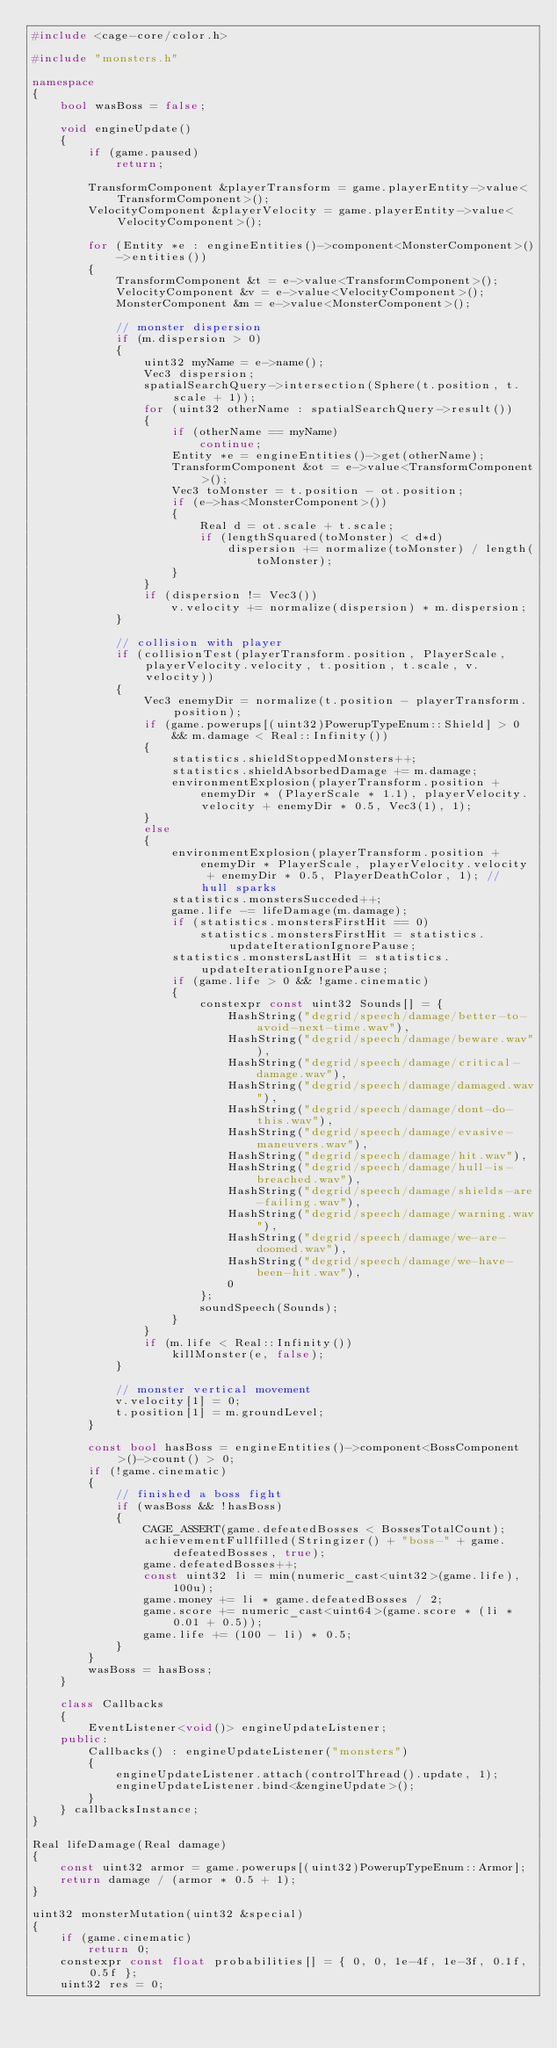Convert code to text. <code><loc_0><loc_0><loc_500><loc_500><_C++_>#include <cage-core/color.h>

#include "monsters.h"

namespace
{
	bool wasBoss = false;

	void engineUpdate()
	{
		if (game.paused)
			return;

		TransformComponent &playerTransform = game.playerEntity->value<TransformComponent>();
		VelocityComponent &playerVelocity = game.playerEntity->value<VelocityComponent>();

		for (Entity *e : engineEntities()->component<MonsterComponent>()->entities())
		{
			TransformComponent &t = e->value<TransformComponent>();
			VelocityComponent &v = e->value<VelocityComponent>();
			MonsterComponent &m = e->value<MonsterComponent>();

			// monster dispersion
			if (m.dispersion > 0)
			{
				uint32 myName = e->name();
				Vec3 dispersion;
				spatialSearchQuery->intersection(Sphere(t.position, t.scale + 1));
				for (uint32 otherName : spatialSearchQuery->result())
				{
					if (otherName == myName)
						continue;
					Entity *e = engineEntities()->get(otherName);
					TransformComponent &ot = e->value<TransformComponent>();
					Vec3 toMonster = t.position - ot.position;
					if (e->has<MonsterComponent>())
					{
						Real d = ot.scale + t.scale;
						if (lengthSquared(toMonster) < d*d)
							dispersion += normalize(toMonster) / length(toMonster);
					}
				}
				if (dispersion != Vec3())
					v.velocity += normalize(dispersion) * m.dispersion;
			}

			// collision with player
			if (collisionTest(playerTransform.position, PlayerScale, playerVelocity.velocity, t.position, t.scale, v.velocity))
			{
				Vec3 enemyDir = normalize(t.position - playerTransform.position);
				if (game.powerups[(uint32)PowerupTypeEnum::Shield] > 0 && m.damage < Real::Infinity())
				{
					statistics.shieldStoppedMonsters++;
					statistics.shieldAbsorbedDamage += m.damage;
					environmentExplosion(playerTransform.position + enemyDir * (PlayerScale * 1.1), playerVelocity.velocity + enemyDir * 0.5, Vec3(1), 1); 
				}
				else
				{
					environmentExplosion(playerTransform.position + enemyDir * PlayerScale, playerVelocity.velocity + enemyDir * 0.5, PlayerDeathColor, 1); // hull sparks
					statistics.monstersSucceded++;
					game.life -= lifeDamage(m.damage);
					if (statistics.monstersFirstHit == 0)
						statistics.monstersFirstHit = statistics.updateIterationIgnorePause;
					statistics.monstersLastHit = statistics.updateIterationIgnorePause;
					if (game.life > 0 && !game.cinematic)
					{
						constexpr const uint32 Sounds[] = {
							HashString("degrid/speech/damage/better-to-avoid-next-time.wav"),
							HashString("degrid/speech/damage/beware.wav"),
							HashString("degrid/speech/damage/critical-damage.wav"),
							HashString("degrid/speech/damage/damaged.wav"),
							HashString("degrid/speech/damage/dont-do-this.wav"),
							HashString("degrid/speech/damage/evasive-maneuvers.wav"),
							HashString("degrid/speech/damage/hit.wav"),
							HashString("degrid/speech/damage/hull-is-breached.wav"),
							HashString("degrid/speech/damage/shields-are-failing.wav"),
							HashString("degrid/speech/damage/warning.wav"),
							HashString("degrid/speech/damage/we-are-doomed.wav"),
							HashString("degrid/speech/damage/we-have-been-hit.wav"),
							0
						};
						soundSpeech(Sounds);
					}
				}
				if (m.life < Real::Infinity())
					killMonster(e, false);
			}

			// monster vertical movement
			v.velocity[1] = 0;
			t.position[1] = m.groundLevel;
		}

		const bool hasBoss = engineEntities()->component<BossComponent>()->count() > 0;
		if (!game.cinematic)
		{
			// finished a boss fight
			if (wasBoss && !hasBoss)
			{
				CAGE_ASSERT(game.defeatedBosses < BossesTotalCount);
				achievementFullfilled(Stringizer() + "boss-" + game.defeatedBosses, true);
				game.defeatedBosses++;
				const uint32 li = min(numeric_cast<uint32>(game.life), 100u);
				game.money += li * game.defeatedBosses / 2;
				game.score += numeric_cast<uint64>(game.score * (li * 0.01 + 0.5));
				game.life += (100 - li) * 0.5;
			}
		}
		wasBoss = hasBoss;
	}

	class Callbacks
	{
		EventListener<void()> engineUpdateListener;
	public:
		Callbacks() : engineUpdateListener("monsters")
		{
			engineUpdateListener.attach(controlThread().update, 1);
			engineUpdateListener.bind<&engineUpdate>();
		}
	} callbacksInstance;
}

Real lifeDamage(Real damage)
{
	const uint32 armor = game.powerups[(uint32)PowerupTypeEnum::Armor];
	return damage / (armor * 0.5 + 1);
}

uint32 monsterMutation(uint32 &special)
{
	if (game.cinematic)
		return 0;
	constexpr const float probabilities[] = { 0, 0, 1e-4f, 1e-3f, 0.1f, 0.5f };
	uint32 res = 0;</code> 